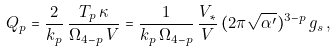<formula> <loc_0><loc_0><loc_500><loc_500>Q _ { p } = \frac { 2 } { k _ { p } } \, \frac { T _ { p } \, \kappa } { \Omega _ { 4 - p } \, V } = \frac { 1 } { k _ { p } \, \Omega _ { 4 - p } } \, \frac { V _ { * } } { V } \, ( 2 \pi \sqrt { \alpha ^ { \prime } } ) ^ { 3 - p } \, g _ { s } \, ,</formula> 